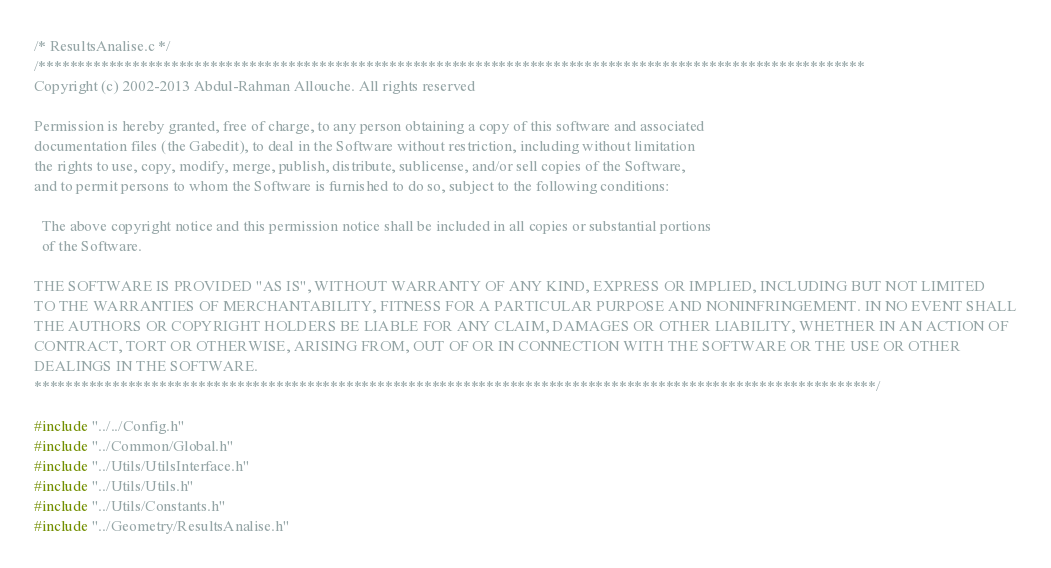<code> <loc_0><loc_0><loc_500><loc_500><_C_>/* ResultsAnalise.c */
/**********************************************************************************************************
Copyright (c) 2002-2013 Abdul-Rahman Allouche. All rights reserved

Permission is hereby granted, free of charge, to any person obtaining a copy of this software and associated
documentation files (the Gabedit), to deal in the Software without restriction, including without limitation
the rights to use, copy, modify, merge, publish, distribute, sublicense, and/or sell copies of the Software,
and to permit persons to whom the Software is furnished to do so, subject to the following conditions:

  The above copyright notice and this permission notice shall be included in all copies or substantial portions
  of the Software.

THE SOFTWARE IS PROVIDED "AS IS", WITHOUT WARRANTY OF ANY KIND, EXPRESS OR IMPLIED, INCLUDING BUT NOT LIMITED
TO THE WARRANTIES OF MERCHANTABILITY, FITNESS FOR A PARTICULAR PURPOSE AND NONINFRINGEMENT. IN NO EVENT SHALL
THE AUTHORS OR COPYRIGHT HOLDERS BE LIABLE FOR ANY CLAIM, DAMAGES OR OTHER LIABILITY, WHETHER IN AN ACTION OF
CONTRACT, TORT OR OTHERWISE, ARISING FROM, OUT OF OR IN CONNECTION WITH THE SOFTWARE OR THE USE OR OTHER
DEALINGS IN THE SOFTWARE.
************************************************************************************************************/

#include "../../Config.h"
#include "../Common/Global.h"
#include "../Utils/UtilsInterface.h"
#include "../Utils/Utils.h"
#include "../Utils/Constants.h"
#include "../Geometry/ResultsAnalise.h"</code> 